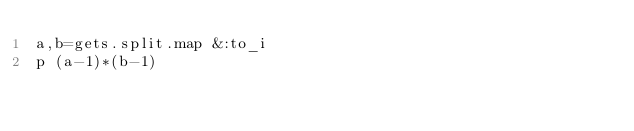Convert code to text. <code><loc_0><loc_0><loc_500><loc_500><_Ruby_>a,b=gets.split.map &:to_i
p (a-1)*(b-1)</code> 